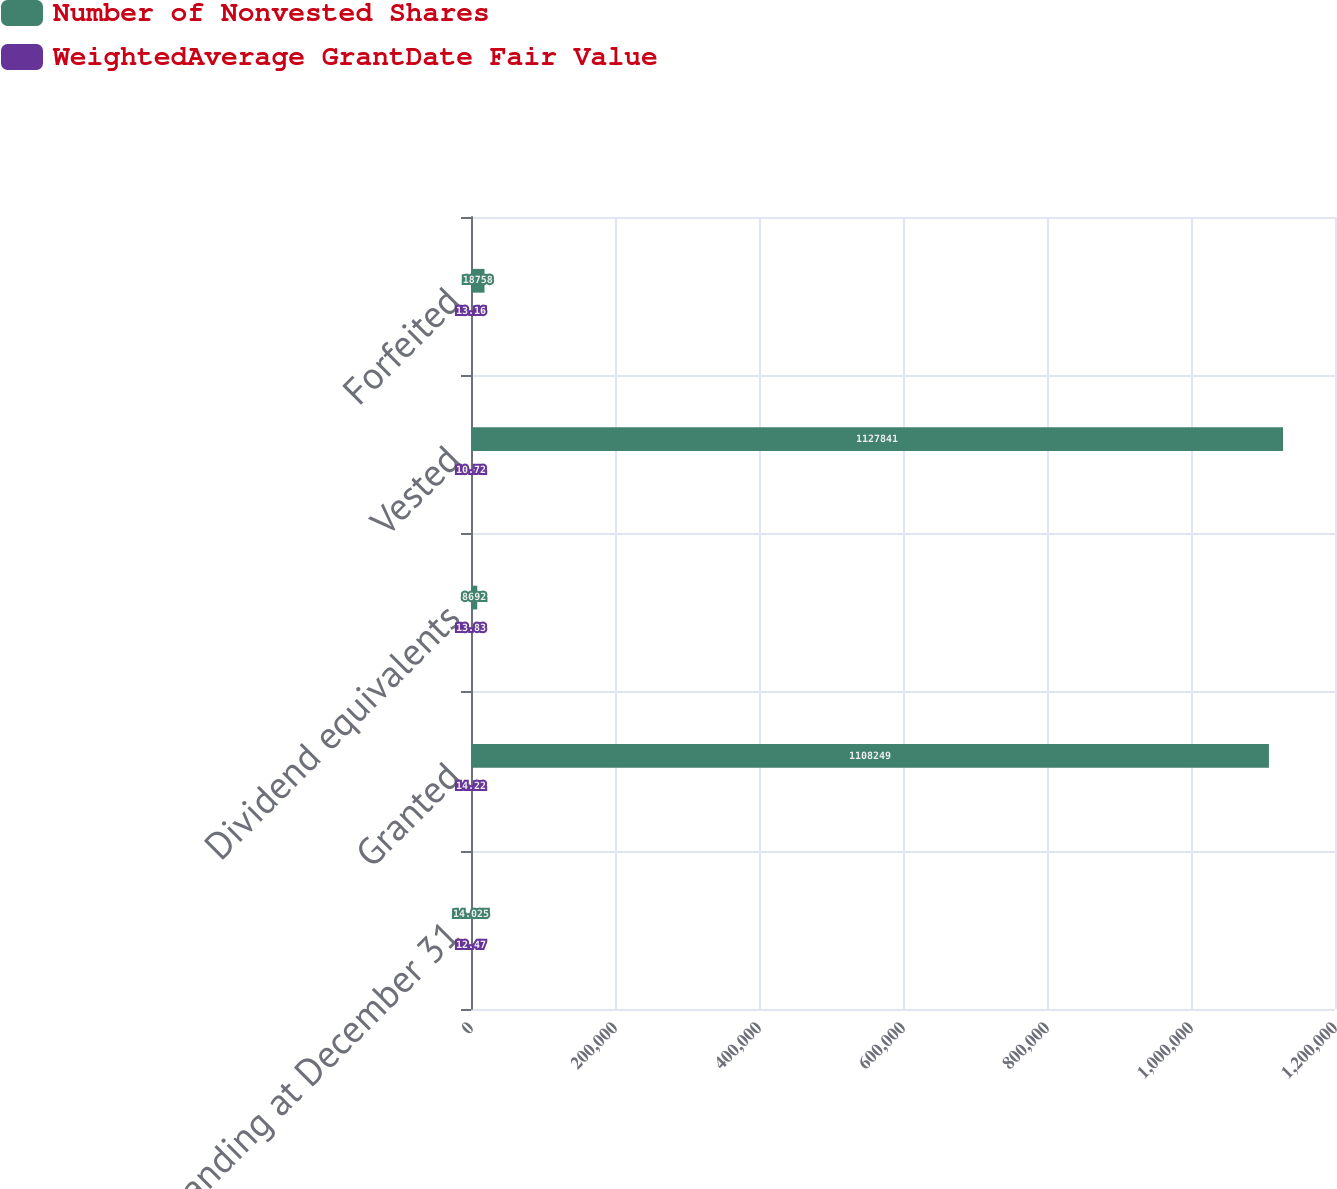<chart> <loc_0><loc_0><loc_500><loc_500><stacked_bar_chart><ecel><fcel>Outstanding at December 31<fcel>Granted<fcel>Dividend equivalents<fcel>Vested<fcel>Forfeited<nl><fcel>Number of Nonvested Shares<fcel>14.025<fcel>1.10825e+06<fcel>8692<fcel>1.12784e+06<fcel>18758<nl><fcel>WeightedAverage GrantDate Fair Value<fcel>12.47<fcel>14.22<fcel>13.83<fcel>10.72<fcel>13.16<nl></chart> 